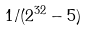<formula> <loc_0><loc_0><loc_500><loc_500>1 / ( 2 ^ { 3 2 } - 5 )</formula> 